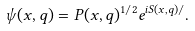<formula> <loc_0><loc_0><loc_500><loc_500>\psi ( x , q ) = P ( x , q ) ^ { 1 / 2 } e ^ { i S ( x , q ) / } .</formula> 